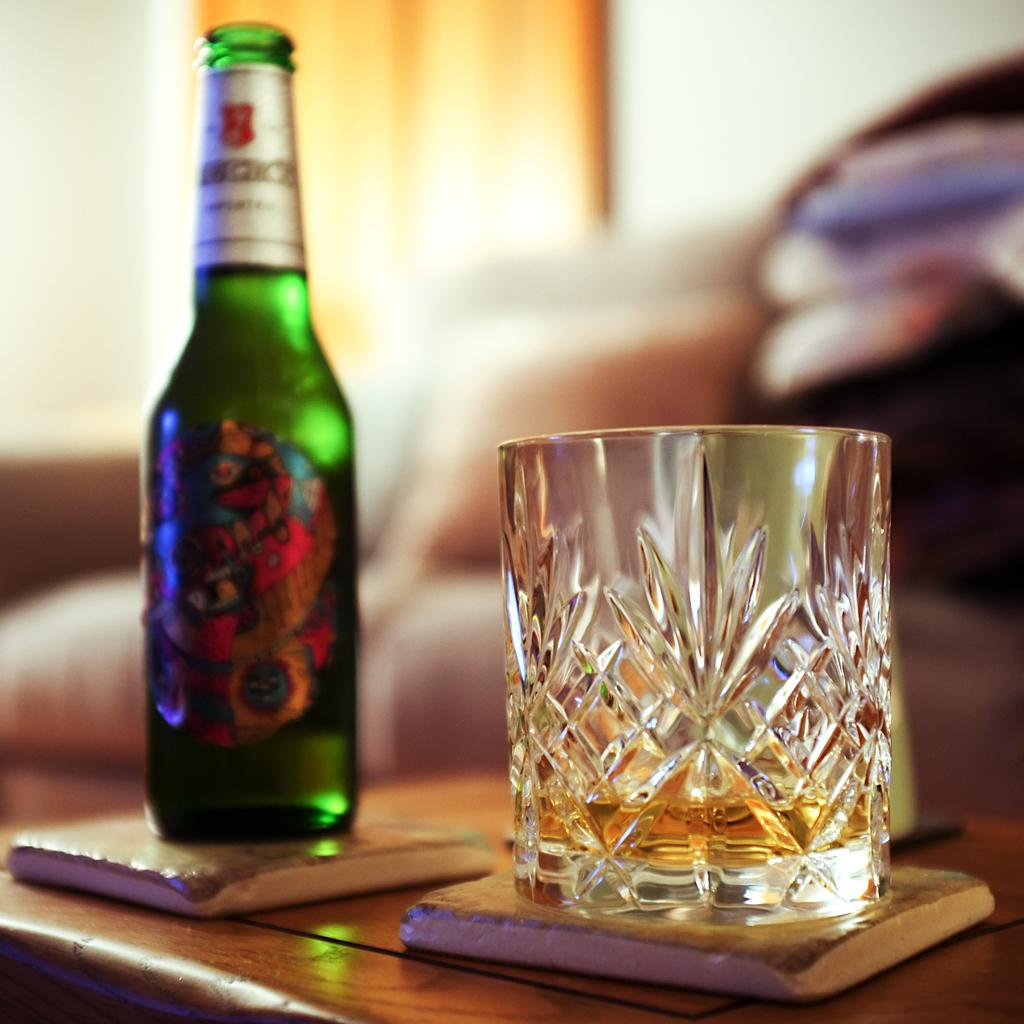<image>
Create a compact narrative representing the image presented. a bottle of bucks beer next to a lightly filled glass 